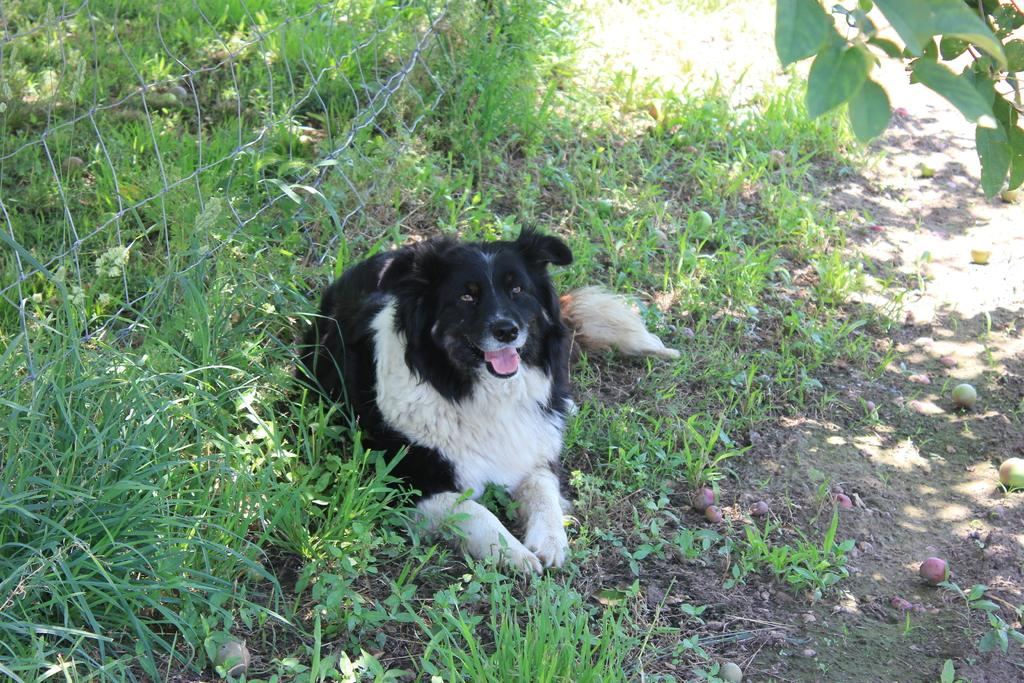What animal can be seen on the land in the image? There is a dog on the land in the image. What type of vegetation is present on the land? The land has grass and plants. What is the purpose of the fence in the image? The fence is on the left side of the image, possibly to mark a boundary or keep the dog contained. What type of food can be seen on the land? There are fruits on the land. What can be seen in the right top part of the image? There are stems with leaves in the right top part of the image. What book is the dog reading in the image? There is no book present in the image; it features a dog on the land with grass, plants, fruits, and stems with leaves. 